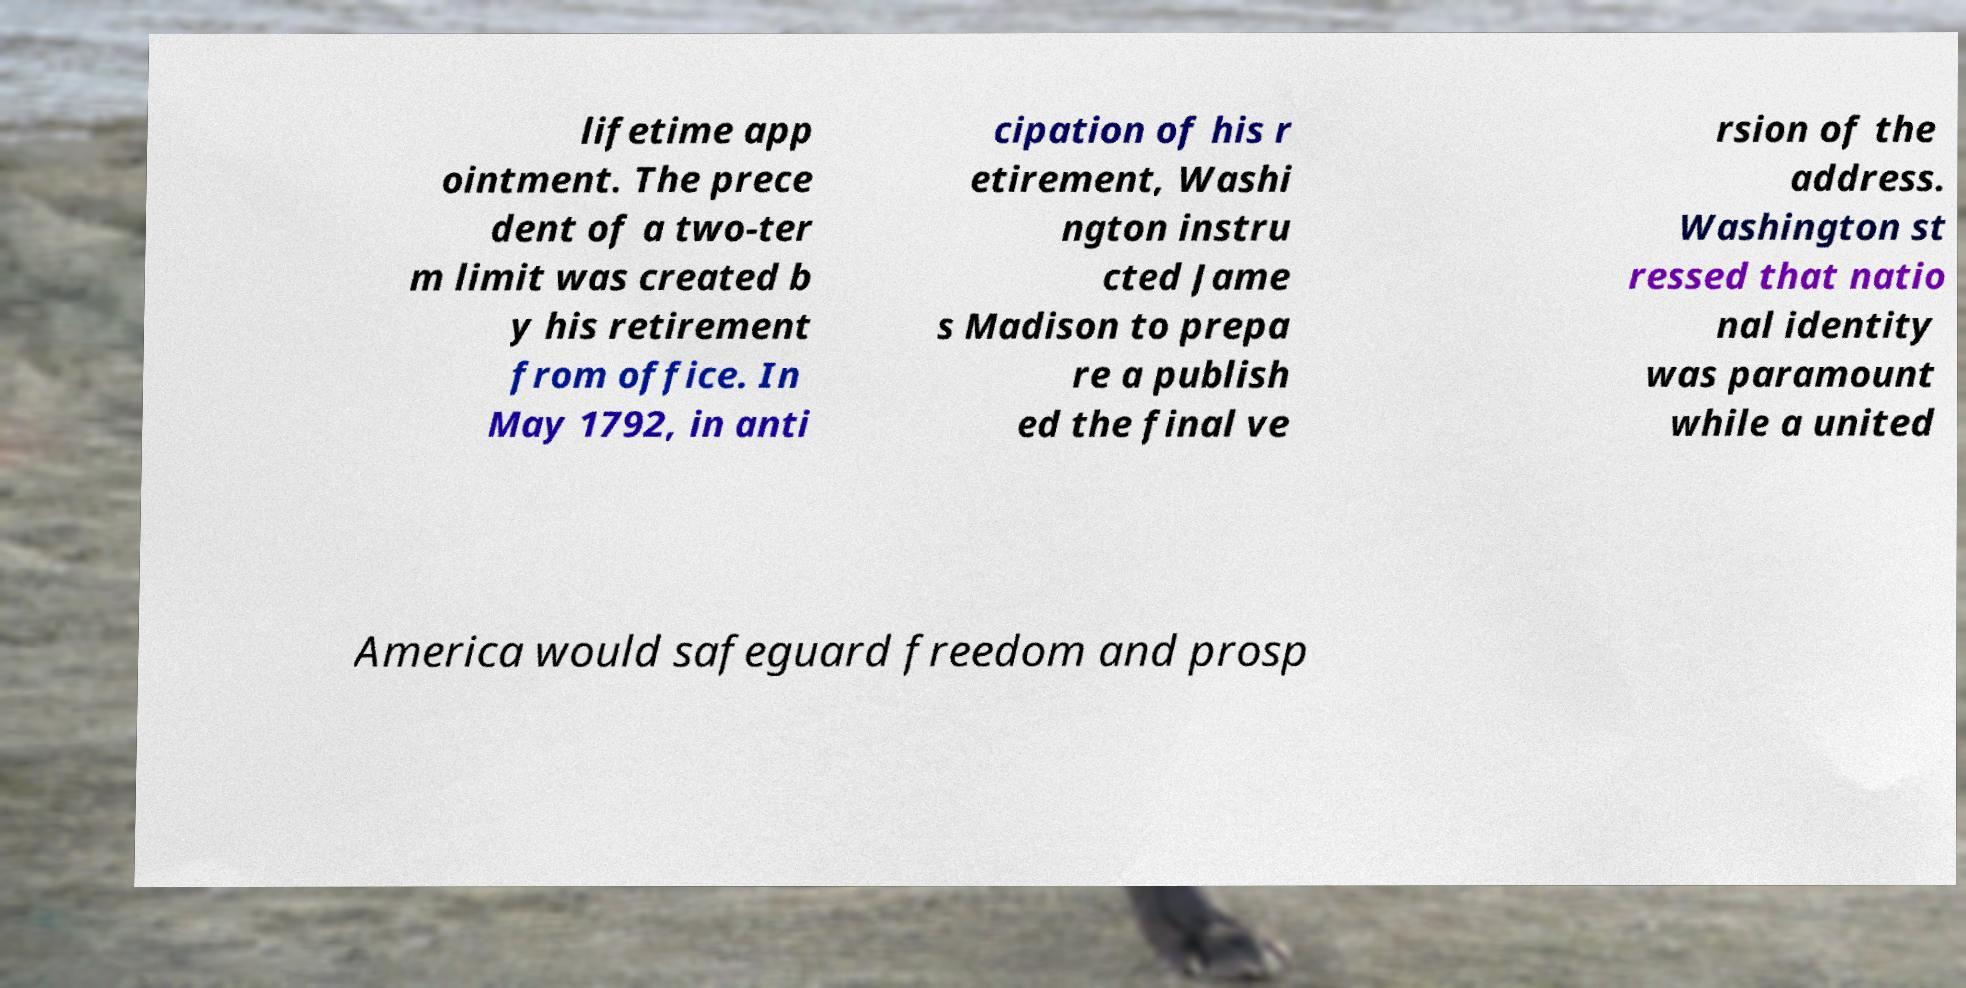Can you read and provide the text displayed in the image?This photo seems to have some interesting text. Can you extract and type it out for me? lifetime app ointment. The prece dent of a two-ter m limit was created b y his retirement from office. In May 1792, in anti cipation of his r etirement, Washi ngton instru cted Jame s Madison to prepa re a publish ed the final ve rsion of the address. Washington st ressed that natio nal identity was paramount while a united America would safeguard freedom and prosp 